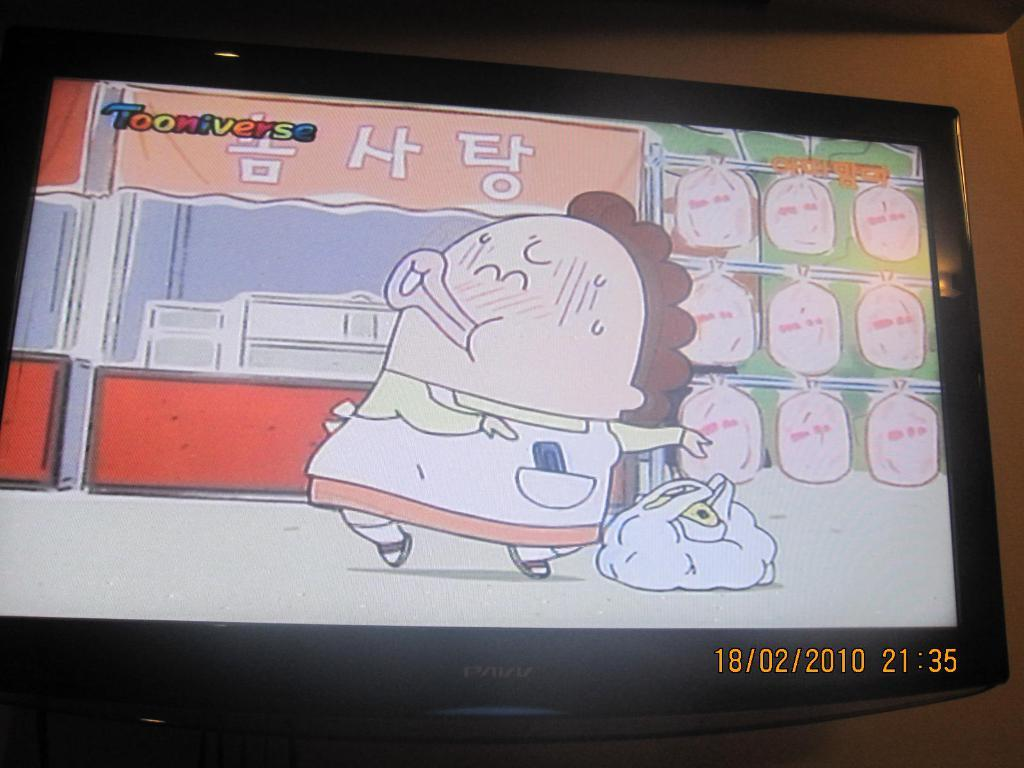What is the main object in the image? There is a screen in the image. What is shown on the screen? The screen displays a cartoon image and text. Can you tell the date and time from the image? Yes, the date and time are visible in the bottom right corner of the image. What can be seen in the background of the image? There is a wall in the background of the image. How many men are taking a bath in the image? There are no men or baths present in the image; it features a screen displaying a cartoon image and text. What type of record is being played in the image? There is no record or any indication of music playing in the image; it only shows a screen with a cartoon image and text. 